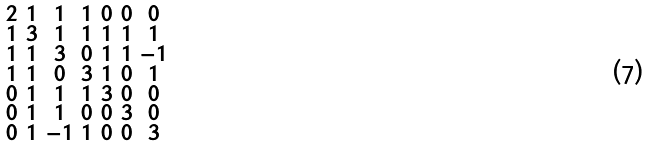<formula> <loc_0><loc_0><loc_500><loc_500>\begin{smallmatrix} 2 & 1 & 1 & 1 & 0 & 0 & 0 \\ 1 & 3 & 1 & 1 & 1 & 1 & 1 \\ 1 & 1 & 3 & 0 & 1 & 1 & - 1 \\ 1 & 1 & 0 & 3 & 1 & 0 & 1 \\ 0 & 1 & 1 & 1 & 3 & 0 & 0 \\ 0 & 1 & 1 & 0 & 0 & 3 & 0 \\ 0 & 1 & - 1 & 1 & 0 & 0 & 3 \end{smallmatrix}</formula> 